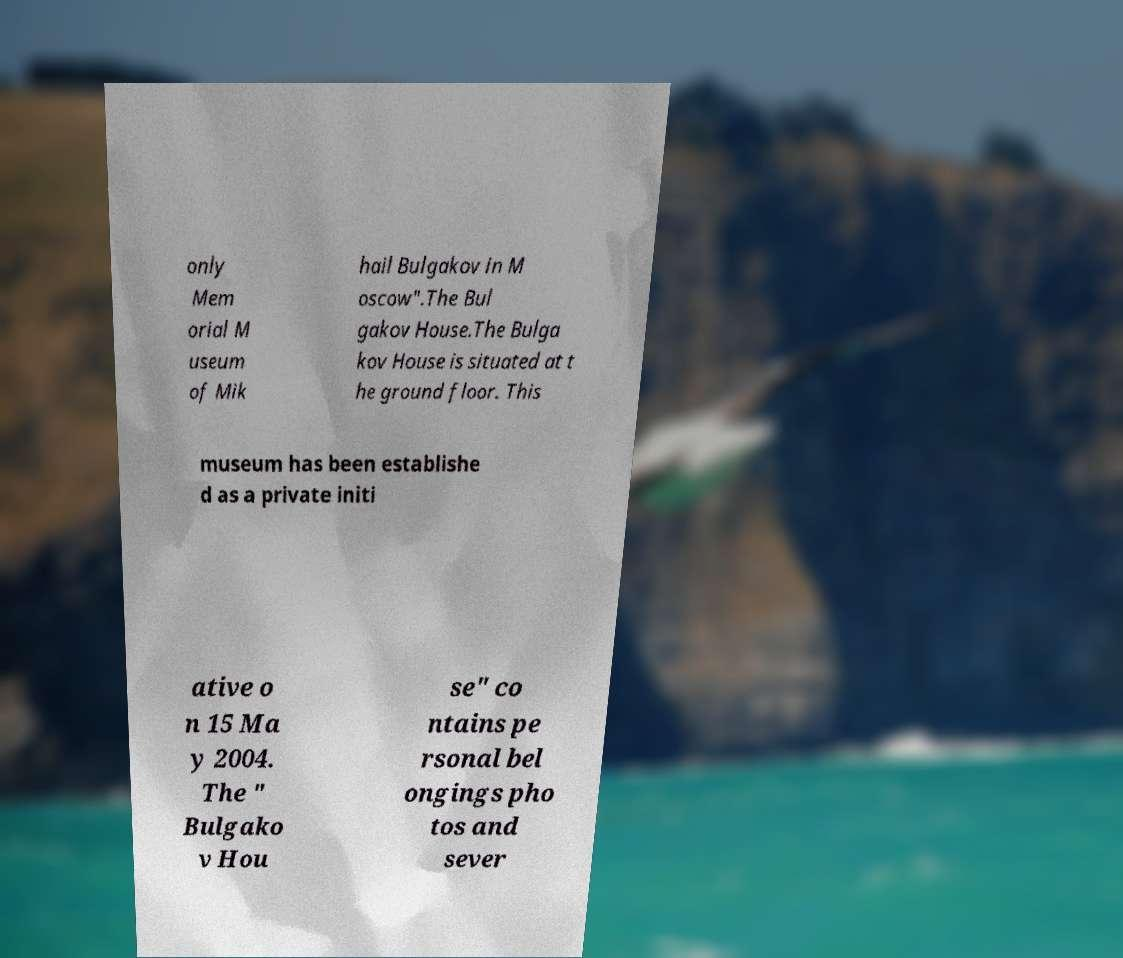Can you read and provide the text displayed in the image?This photo seems to have some interesting text. Can you extract and type it out for me? only Mem orial M useum of Mik hail Bulgakov in M oscow".The Bul gakov House.The Bulga kov House is situated at t he ground floor. This museum has been establishe d as a private initi ative o n 15 Ma y 2004. The " Bulgako v Hou se" co ntains pe rsonal bel ongings pho tos and sever 